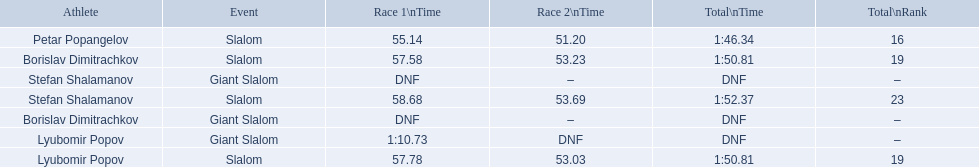What were the event names during bulgaria at the 1988 winter olympics? Stefan Shalamanov, Borislav Dimitrachkov, Lyubomir Popov. And which players participated at giant slalom? Giant Slalom, Giant Slalom, Giant Slalom, Slalom, Slalom, Slalom, Slalom. What were their race 1 times? DNF, DNF, 1:10.73. What was lyubomir popov's personal time? 1:10.73. 